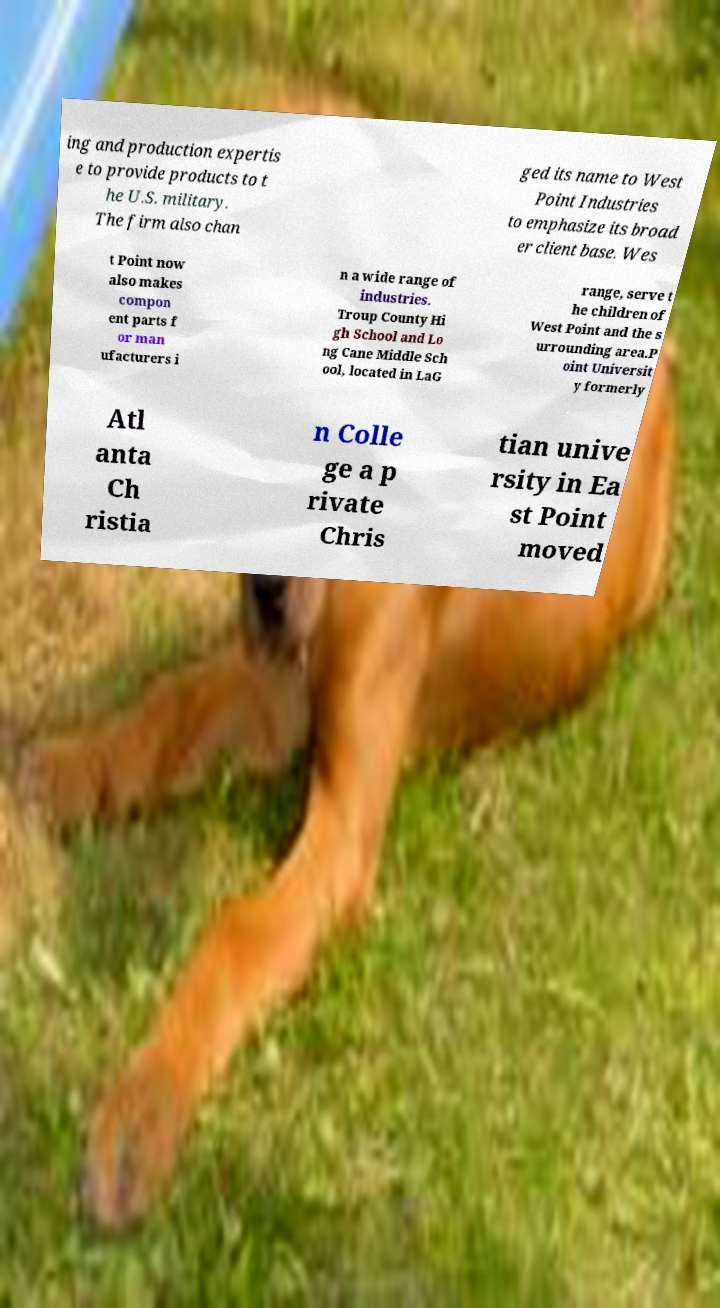What messages or text are displayed in this image? I need them in a readable, typed format. ing and production expertis e to provide products to t he U.S. military. The firm also chan ged its name to West Point Industries to emphasize its broad er client base. Wes t Point now also makes compon ent parts f or man ufacturers i n a wide range of industries. Troup County Hi gh School and Lo ng Cane Middle Sch ool, located in LaG range, serve t he children of West Point and the s urrounding area.P oint Universit y formerly Atl anta Ch ristia n Colle ge a p rivate Chris tian unive rsity in Ea st Point moved 